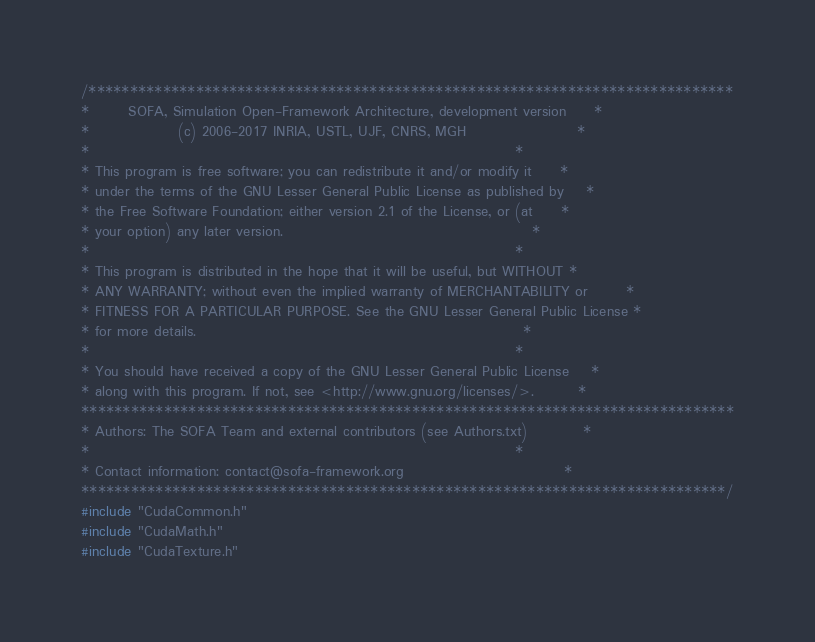<code> <loc_0><loc_0><loc_500><loc_500><_Cuda_>/******************************************************************************
*       SOFA, Simulation Open-Framework Architecture, development version     *
*                (c) 2006-2017 INRIA, USTL, UJF, CNRS, MGH                    *
*                                                                             *
* This program is free software; you can redistribute it and/or modify it     *
* under the terms of the GNU Lesser General Public License as published by    *
* the Free Software Foundation; either version 2.1 of the License, or (at     *
* your option) any later version.                                             *
*                                                                             *
* This program is distributed in the hope that it will be useful, but WITHOUT *
* ANY WARRANTY; without even the implied warranty of MERCHANTABILITY or       *
* FITNESS FOR A PARTICULAR PURPOSE. See the GNU Lesser General Public License *
* for more details.                                                           *
*                                                                             *
* You should have received a copy of the GNU Lesser General Public License    *
* along with this program. If not, see <http://www.gnu.org/licenses/>.        *
*******************************************************************************
* Authors: The SOFA Team and external contributors (see Authors.txt)          *
*                                                                             *
* Contact information: contact@sofa-framework.org                             *
******************************************************************************/
#include "CudaCommon.h"
#include "CudaMath.h"
#include "CudaTexture.h"</code> 